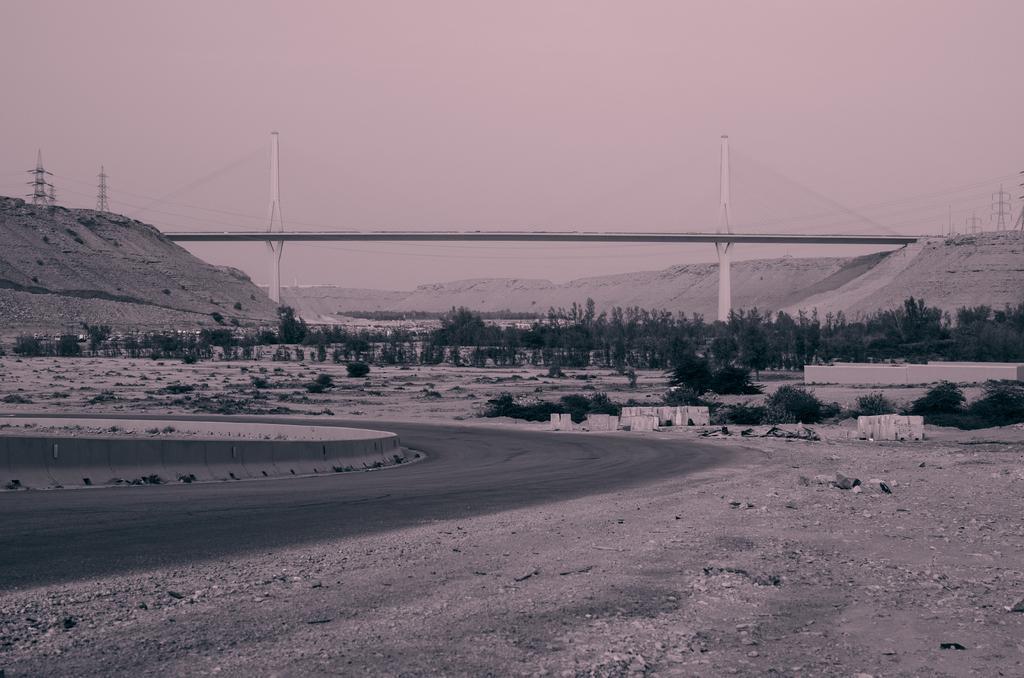Describe this image in one or two sentences. In this image in the background there are trees and there are towers there is a bridge. In the front there is a road and there are stones on the ground. 